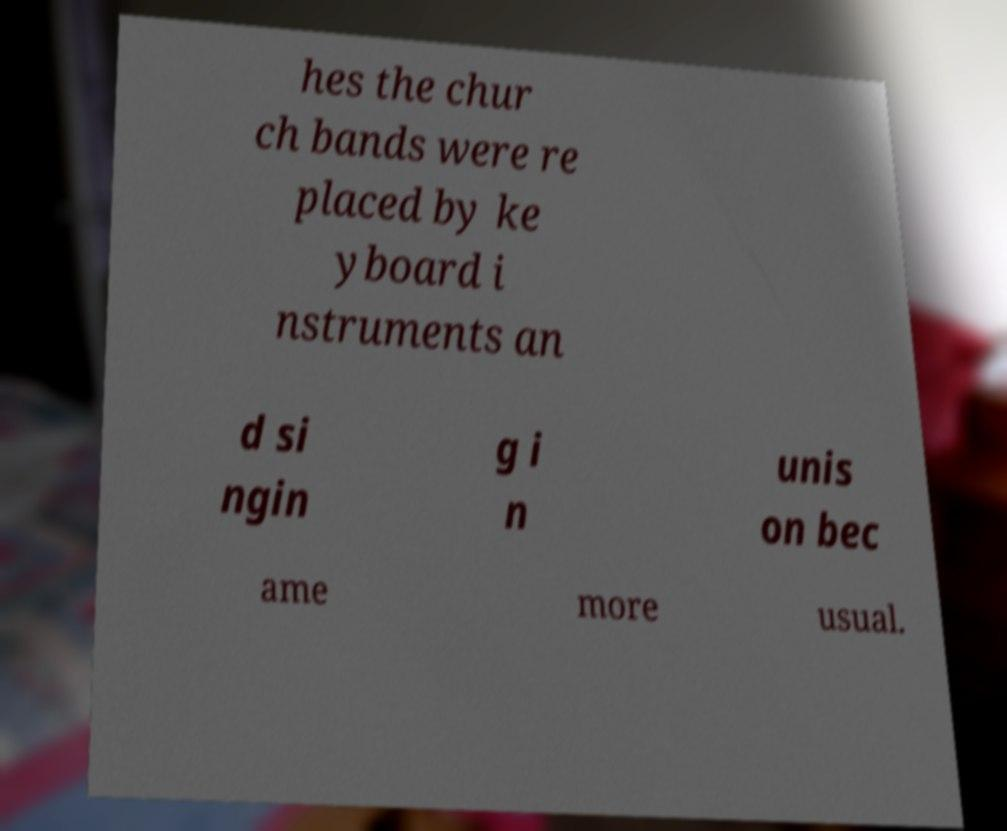Can you accurately transcribe the text from the provided image for me? hes the chur ch bands were re placed by ke yboard i nstruments an d si ngin g i n unis on bec ame more usual. 